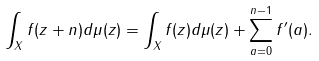Convert formula to latex. <formula><loc_0><loc_0><loc_500><loc_500>\int _ { X } f ( z + n ) d \mu ( z ) = \int _ { X } f ( z ) d \mu ( z ) + \sum _ { a = 0 } ^ { n - 1 } f ^ { \prime } ( a ) .</formula> 